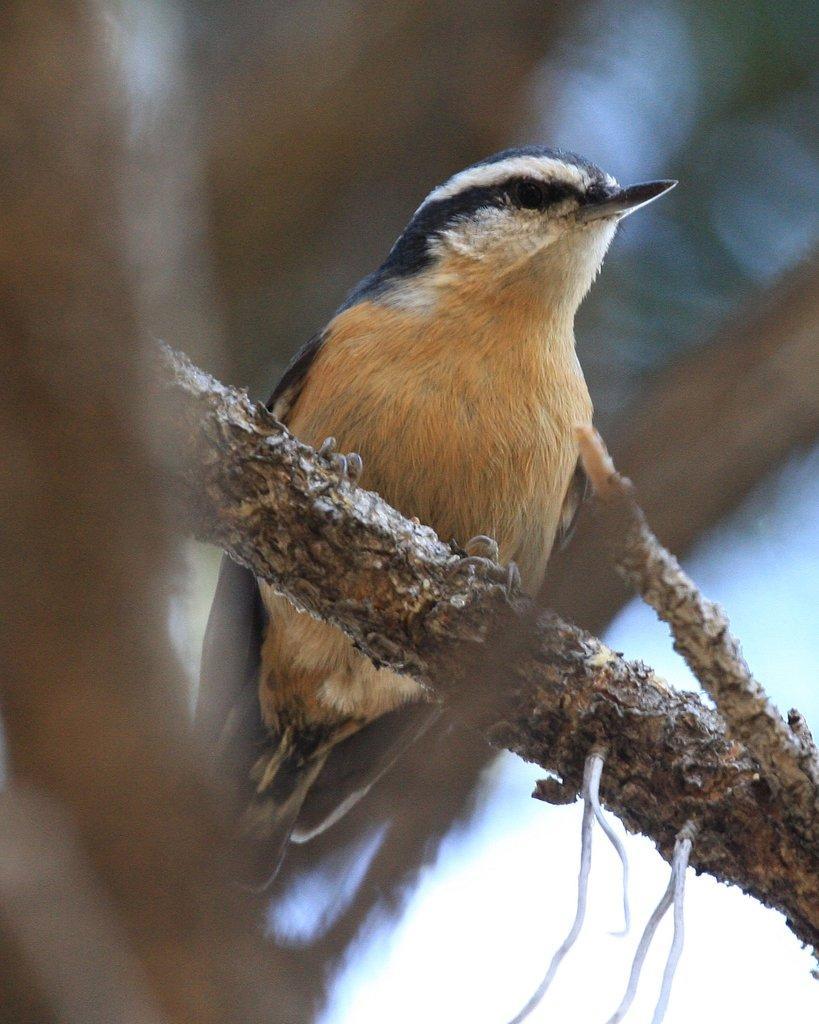Describe this image in one or two sentences. In this image we can see a bird on the branch of a tree. In the background there is sky. 